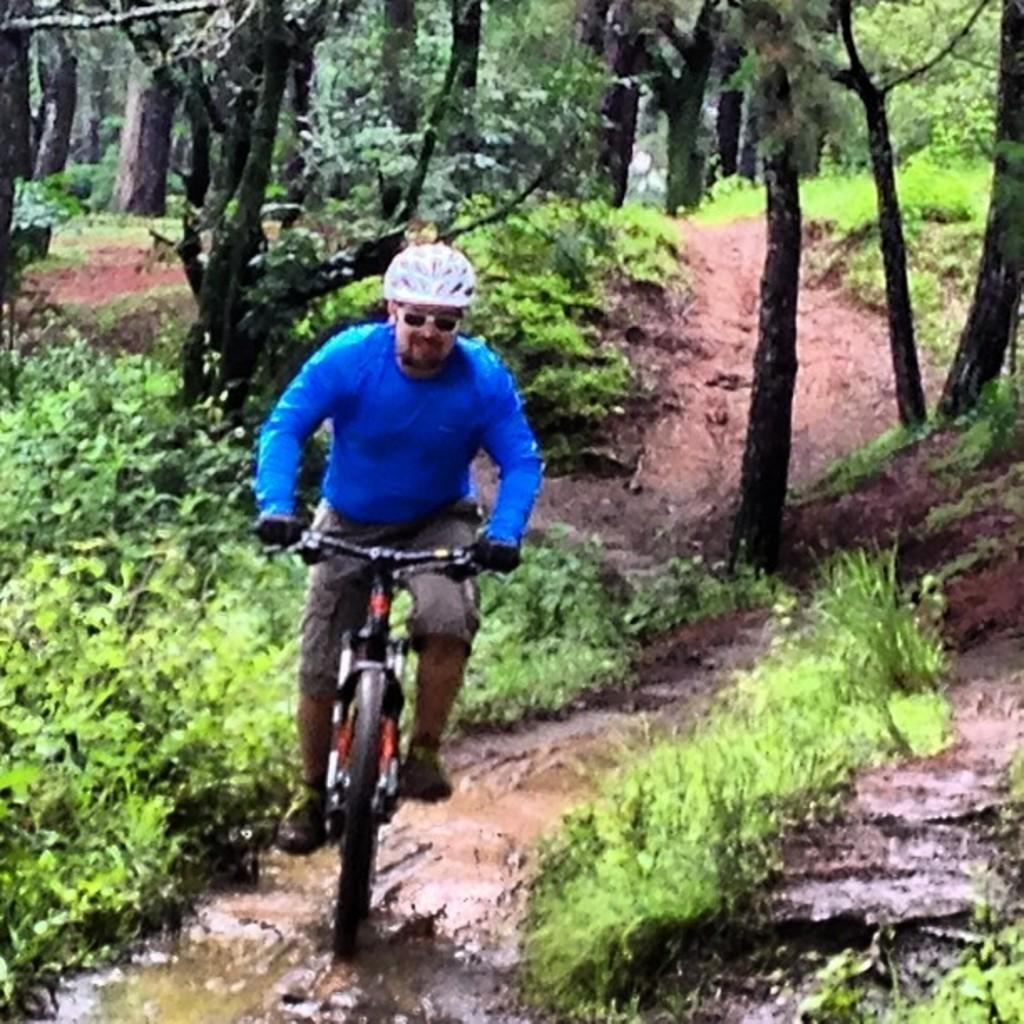What is the person in the image doing? The person is riding a bicycle in the image. What safety precaution is the person taking while riding the bicycle? The person is wearing a helmet. What can be seen at the bottom of the image? There is mud and grass at the bottom of the image. What type of natural environment is visible in the background of the image? There are trees in the background of the image. Can you see a clam in the image? No, there is no clam present in the image. What type of key is used to unlock the bicycle in the image? There is no key visible in the image, as the person is already riding the bicycle. 